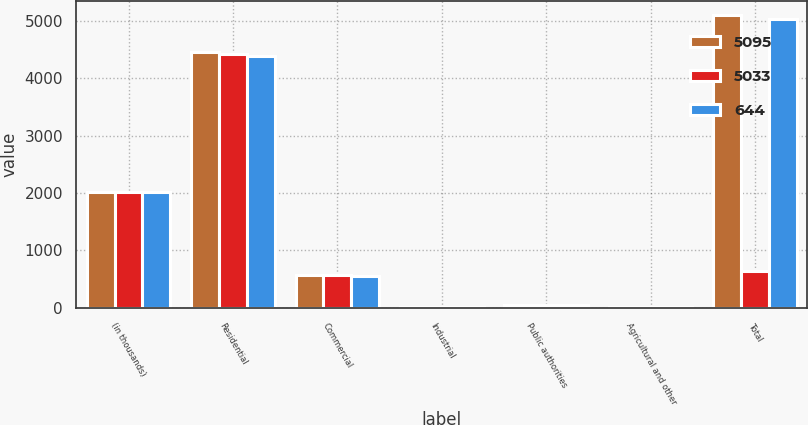Convert chart. <chart><loc_0><loc_0><loc_500><loc_500><stacked_bar_chart><ecel><fcel>(in thousands)<fcel>Residential<fcel>Commercial<fcel>Industrial<fcel>Public authorities<fcel>Agricultural and other<fcel>Total<nl><fcel>5095<fcel>2017<fcel>4448<fcel>569<fcel>10<fcel>46<fcel>22<fcel>5095<nl><fcel>5033<fcel>2016<fcel>4417<fcel>565<fcel>10<fcel>46<fcel>23<fcel>644<nl><fcel>644<fcel>2015<fcel>4393<fcel>561<fcel>11<fcel>46<fcel>22<fcel>5033<nl></chart> 